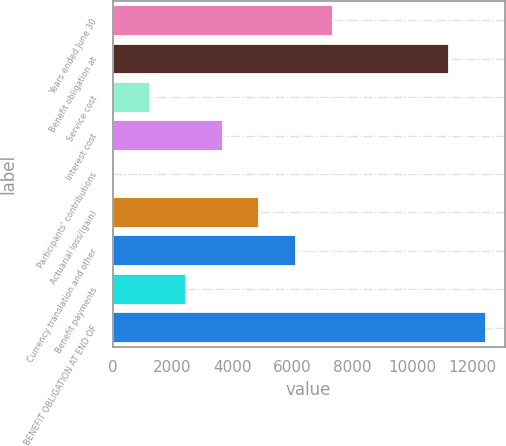<chart> <loc_0><loc_0><loc_500><loc_500><bar_chart><fcel>Years ended June 30<fcel>Benefit obligation at<fcel>Service cost<fcel>Interest cost<fcel>Participants' contributions<fcel>Actuarial loss/(gain)<fcel>Currency translation and other<fcel>Benefit payments<fcel>BENEFIT OBLIGATION AT END OF<nl><fcel>7345.8<fcel>11245<fcel>1241.8<fcel>3683.4<fcel>21<fcel>4904.2<fcel>6125<fcel>2462.6<fcel>12465.8<nl></chart> 